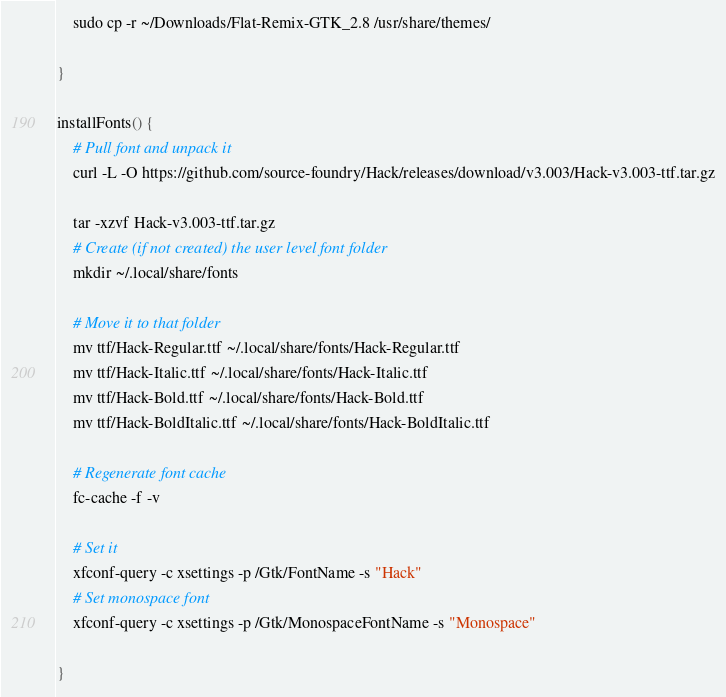Convert code to text. <code><loc_0><loc_0><loc_500><loc_500><_Bash_>	sudo cp -r ~/Downloads/Flat-Remix-GTK_2.8 /usr/share/themes/

}

installFonts() {
	# Pull font and unpack it
	curl -L -O https://github.com/source-foundry/Hack/releases/download/v3.003/Hack-v3.003-ttf.tar.gz

	tar -xzvf Hack-v3.003-ttf.tar.gz
	# Create (if not created) the user level font folder
	mkdir ~/.local/share/fonts

	# Move it to that folder
	mv ttf/Hack-Regular.ttf ~/.local/share/fonts/Hack-Regular.ttf
	mv ttf/Hack-Italic.ttf ~/.local/share/fonts/Hack-Italic.ttf
	mv ttf/Hack-Bold.ttf ~/.local/share/fonts/Hack-Bold.ttf
	mv ttf/Hack-BoldItalic.ttf ~/.local/share/fonts/Hack-BoldItalic.ttf

	# Regenerate font cache
	fc-cache -f -v

	# Set it 
	xfconf-query -c xsettings -p /Gtk/FontName -s "Hack"
	# Set monospace font
	xfconf-query -c xsettings -p /Gtk/MonospaceFontName -s "Monospace"

}</code> 